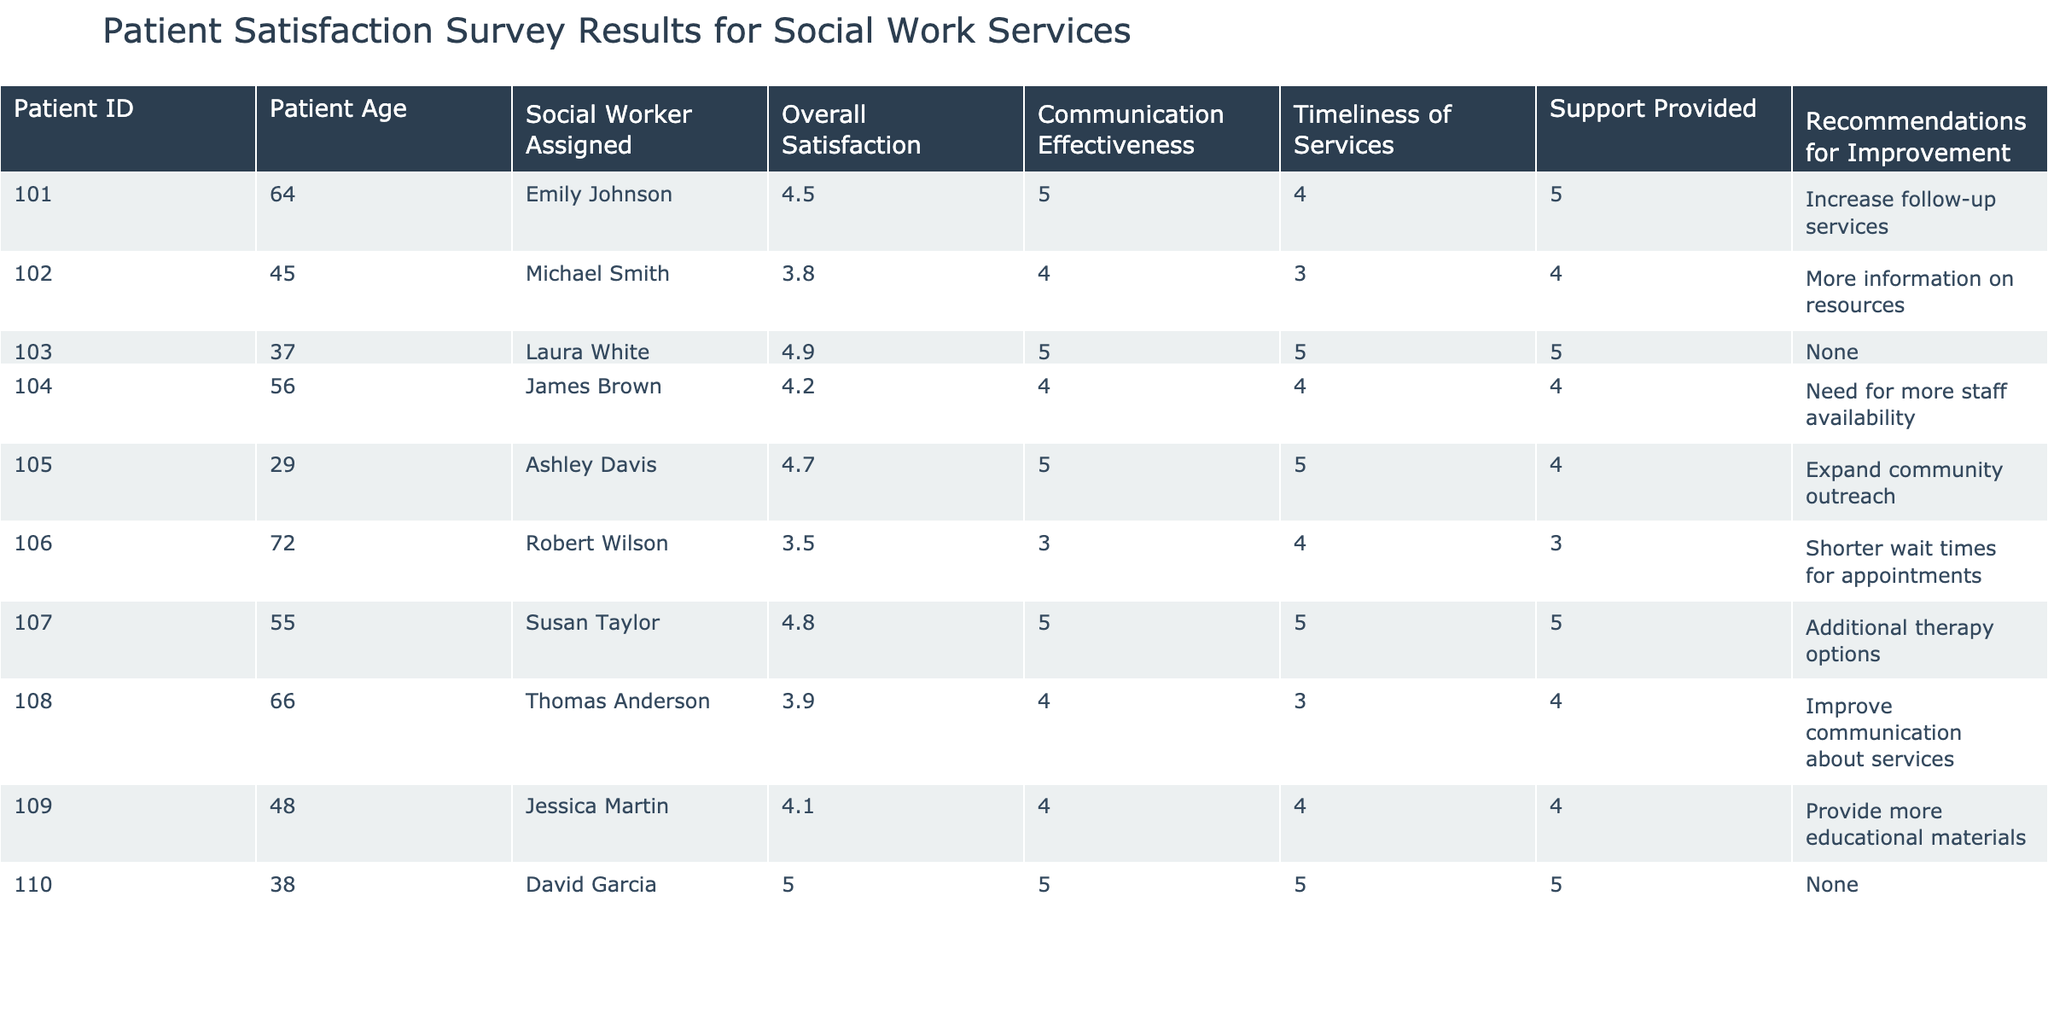What was the overall satisfaction rating of patient ID 110? By looking at the table, I can find the row corresponding to patient ID 110. The Overall Satisfaction rating for that patient is listed in the row for this ID. Therefore, the answer is 5.0.
Answer: 5.0 How many patients rated the Communication Effectiveness as a 5? In the table, I need to look through the Communication Effectiveness column and count the instances where the rating is 5. Upon examination, patient IDs 101, 103, 105, 107, and 110 all have a rating of 5, resulting in a total of 5 patients.
Answer: 5 What is the average rating for Timeliness of Services across all patients? To calculate the average, I first sum the ratings in the Timeliness of Services column: 4 + 3 + 5 + 4 + 5 + 4 + 5 + 3 + 4 + 5 = 46. Then, I divide by the total number of patients (10): 46/10 = 4.6. Therefore, the average rating is 4.6.
Answer: 4.6 Did any patient suggest "None" for Recommendations for Improvement? Looking at the Recommendations for Improvement column, I check for occurrences of the word "None." I see that both patient IDs 103 and 110 have "None" as their suggestion. Hence, the answer is yes.
Answer: Yes Which social worker received the highest combined rating for Overall Satisfaction, Communication Effectiveness, Timeliness of Services, and Support Provided? I calculate the combined ratings for each social worker by adding the respective ratings from each patient assigned to them. For Emily Johnson (IDs 101, 110): (4.5 + 5.0 + 5 + 5) = 19.5; Michael Smith (ID 102): (3.8 + 4) = 7.8; Laura White (ID 103): (4.9 + 5) = 9.9; James Brown (ID 104): (4.2 + 4) = 8.2; Ashley Davis (ID 105): (4.7 + 5) = 9.7; Robert Wilson (ID 106): (3.5 + 3) = 6.5; Susan Taylor (ID 107): (4.8 + 5) = 9.8; Thomas Anderson (ID 108): (3.9 + 4) = 7.9; Jessica Martin (ID 109): (4.1 + 4) = 8.1. The highest combined score is 19.5 from Emily Johnson.
Answer: Emily Johnson 